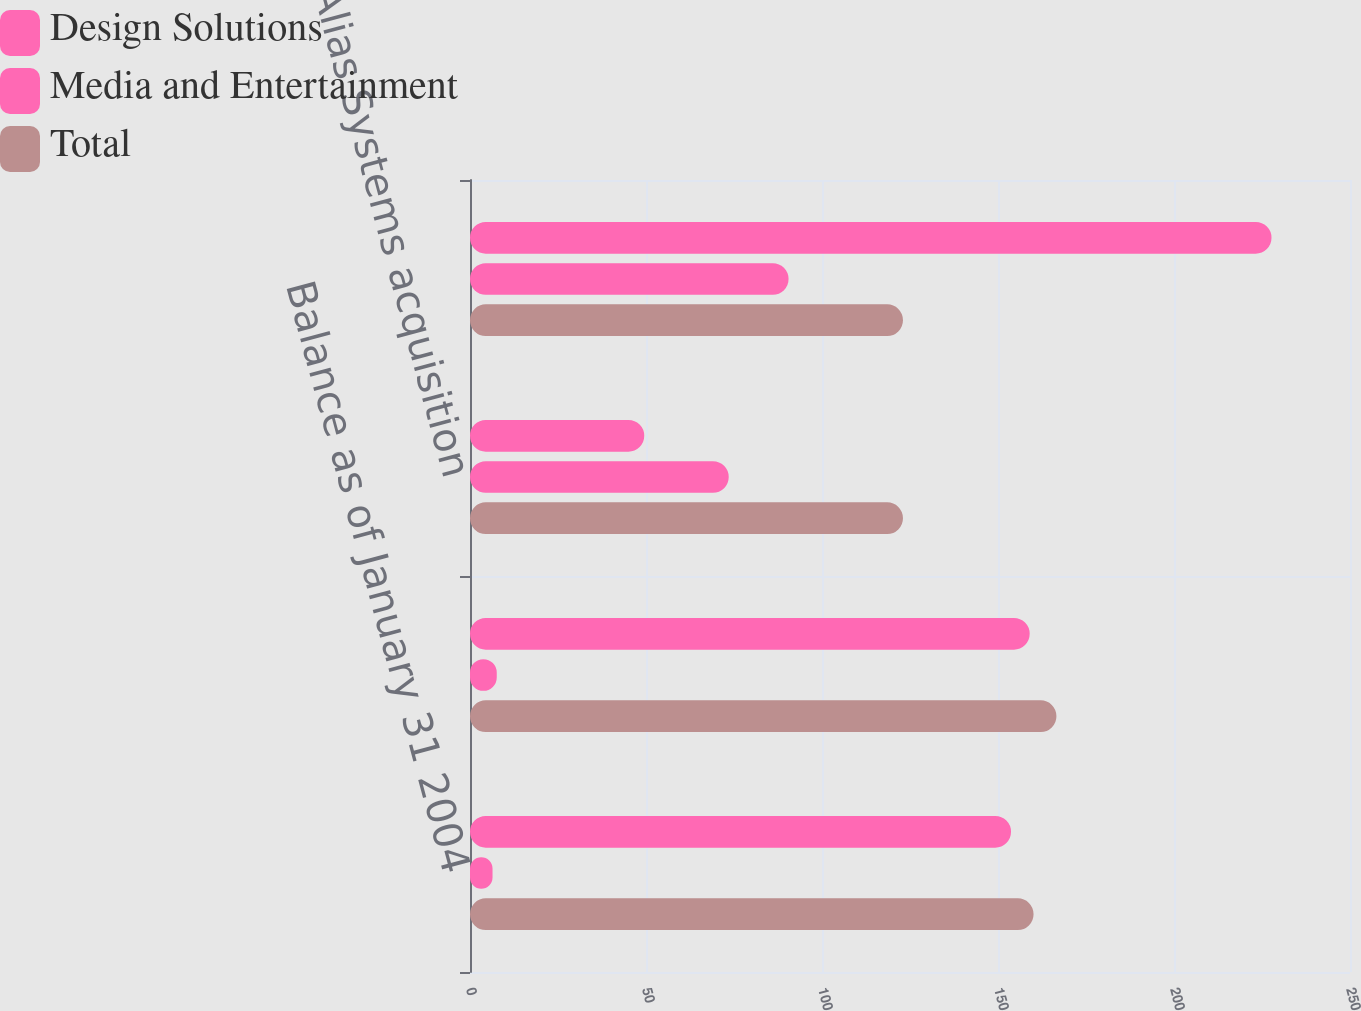Convert chart to OTSL. <chart><loc_0><loc_0><loc_500><loc_500><stacked_bar_chart><ecel><fcel>Balance as of January 31 2004<fcel>Balance as of January 31 2005<fcel>Alias Systems acquisition<fcel>Balance as of January 31 2006<nl><fcel>Design Solutions<fcel>153.7<fcel>159<fcel>49.5<fcel>227.7<nl><fcel>Media and Entertainment<fcel>6.4<fcel>7.6<fcel>73.5<fcel>90.5<nl><fcel>Total<fcel>160.1<fcel>166.6<fcel>123<fcel>123<nl></chart> 